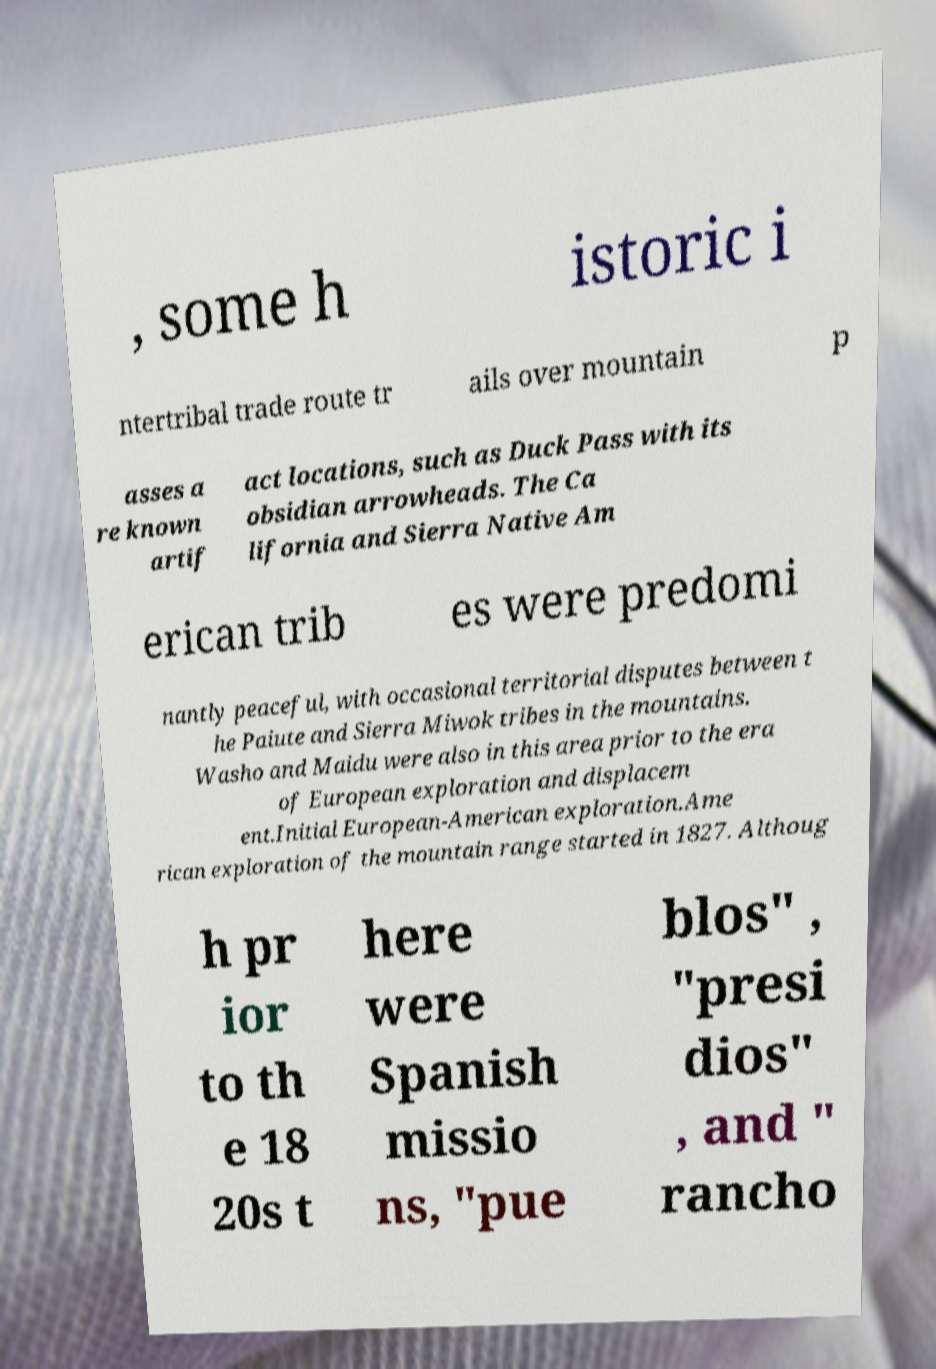I need the written content from this picture converted into text. Can you do that? , some h istoric i ntertribal trade route tr ails over mountain p asses a re known artif act locations, such as Duck Pass with its obsidian arrowheads. The Ca lifornia and Sierra Native Am erican trib es were predomi nantly peaceful, with occasional territorial disputes between t he Paiute and Sierra Miwok tribes in the mountains. Washo and Maidu were also in this area prior to the era of European exploration and displacem ent.Initial European-American exploration.Ame rican exploration of the mountain range started in 1827. Althoug h pr ior to th e 18 20s t here were Spanish missio ns, "pue blos" , "presi dios" , and " rancho 